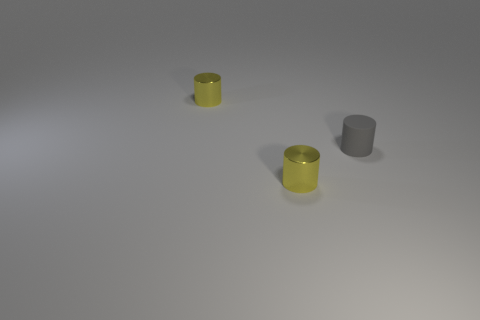Is there any other thing that is the same color as the tiny matte cylinder?
Your response must be concise. No. What is the color of the thing that is left of the yellow shiny cylinder in front of the tiny yellow object that is behind the small gray rubber object?
Keep it short and to the point. Yellow. Is the number of tiny yellow shiny objects on the right side of the tiny gray matte thing the same as the number of objects?
Give a very brief answer. No. Are there any other things that have the same material as the gray cylinder?
Your response must be concise. No. Is there a yellow metal object that is to the right of the yellow metal thing that is to the left of the yellow shiny object in front of the tiny rubber cylinder?
Offer a terse response. Yes. Are there fewer small yellow metallic things that are in front of the tiny gray cylinder than yellow things?
Ensure brevity in your answer.  Yes. How many things are either tiny yellow cylinders in front of the small gray cylinder or yellow cylinders that are in front of the small gray matte cylinder?
Make the answer very short. 1. There is a small yellow object that is behind the small matte cylinder; is its shape the same as the gray rubber object?
Your answer should be compact. Yes. What number of objects are either small gray rubber cylinders or small red metallic spheres?
Make the answer very short. 1. Are there any small matte things left of the gray object?
Keep it short and to the point. No. 